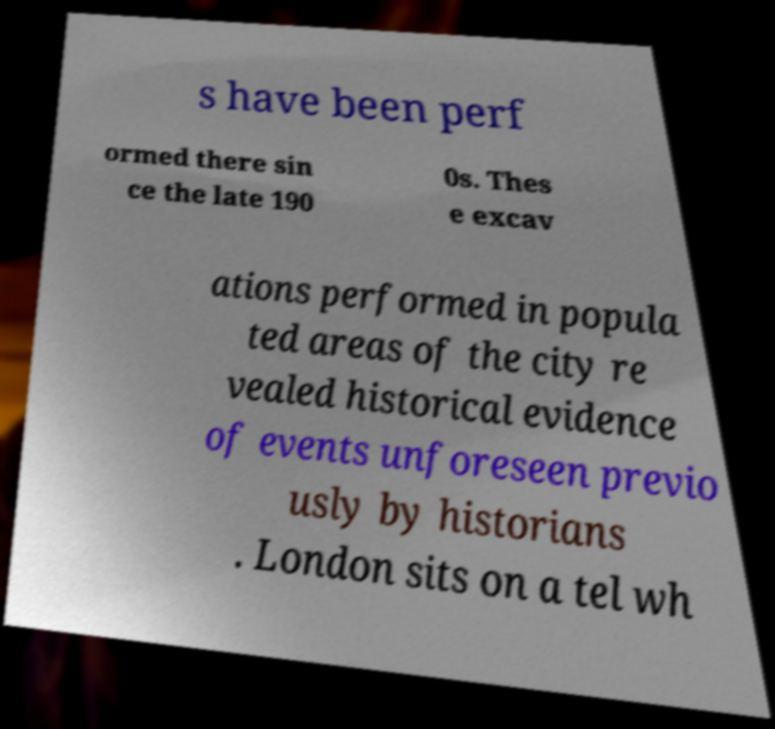For documentation purposes, I need the text within this image transcribed. Could you provide that? s have been perf ormed there sin ce the late 190 0s. Thes e excav ations performed in popula ted areas of the city re vealed historical evidence of events unforeseen previo usly by historians . London sits on a tel wh 